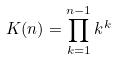Convert formula to latex. <formula><loc_0><loc_0><loc_500><loc_500>K ( n ) = \prod _ { k = 1 } ^ { n - 1 } k ^ { k }</formula> 